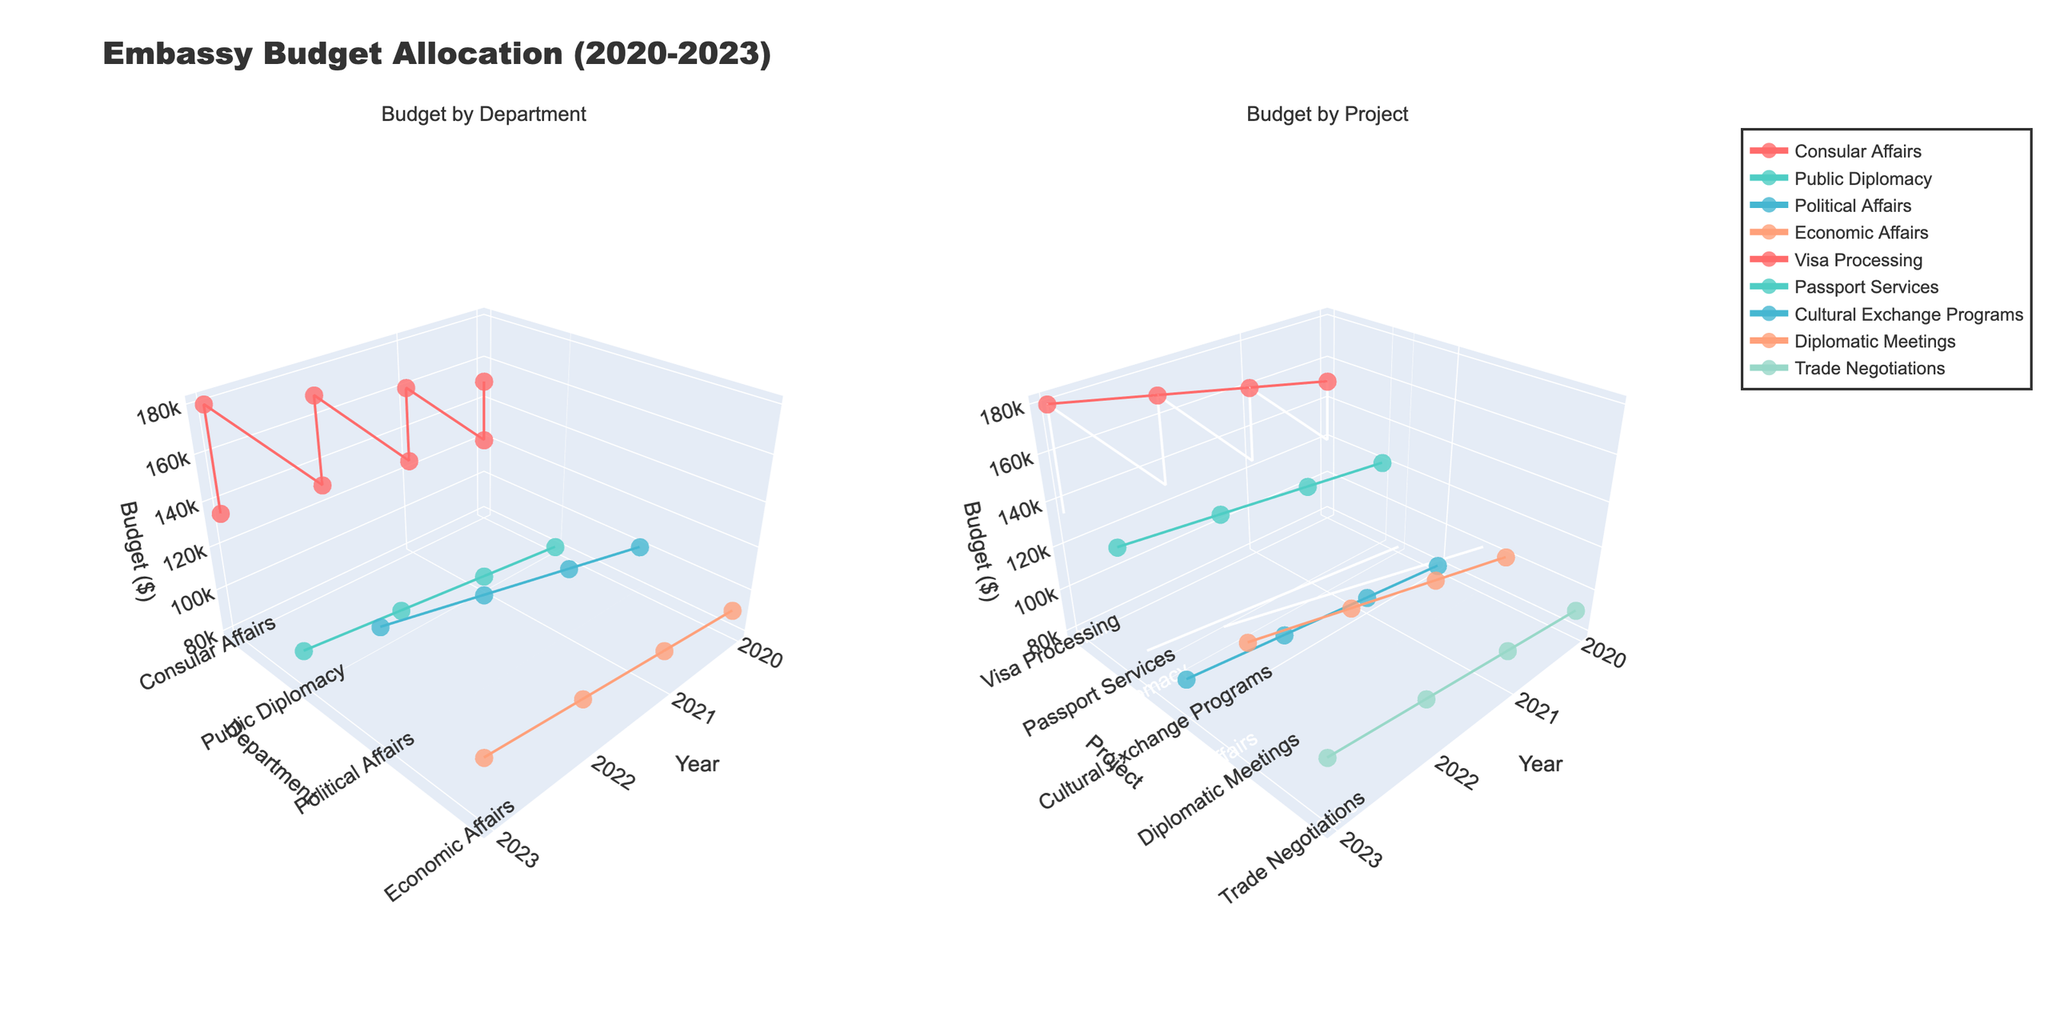What's the title of the plot? The title of the plot is shown prominently at the top of the figure. It summarizes the main subject of the plot.
Answer: Embassy Budget Allocation (2020-2023) How many departments are detailed in the left subplot? The left subplot plots the budget by department over time. Count each unique department listed along the y-axis.
Answer: 5 Which department had the highest budget in 2023? Look at the left subplot under the year 2023 and identify the department with the highest value on the z-axis.
Answer: Consular Affairs (Visa Processing) What's the budget trend for the Trade Negotiations project from 2020 to 2023? In the right subplot, find the Trade Negotiations project and observe how the budget changes from 2020 to 2023. The line connecting the points indicates the trend.
Answer: Increasing Which project had the lowest budget in 2020? In the right subplot, look for the year 2020 and identify the project with the lowest budget value on the z-axis.
Answer: Cultural Exchange Programs By how much did the budget for Visa Processing increase from 2020 to 2023? In the right subplot, locate the budget for Visa Processing in 2020 and 2023, then calculate the difference.
Answer: $30000 How does the trend of the budget allocation in Public Diplomacy compare to Political Affairs from 2020 to 2023? Compare the lines representing Public Diplomacy and Political Affairs departments in the left subplot, noting changes in the budget values from 2020 to 2023.
Answer: Public Diplomacy shows a slight but steady increase, while Political Affairs has a more pronounced increase What is the consistency of budget increases across all projects from 2020 to 2023? Observe the right subplot, noting the trend lines for all projects. Identify if each project has an increase and if those increases are steady or fluctuating.
Answer: All projects have a steady increase What department received the lowest budget in 2021? Examine the left subplot and locate the year 2021, then find the department with the lowest z-axis value (budget).
Answer: Public Diplomacy Which year's budget for Passport Services shows the most significant increase compared to the previous year? In the right subplot, find the budget values for Passport Services across the years, then identify the year with the largest jump in budget compared to the previous year.
Answer: 2021 